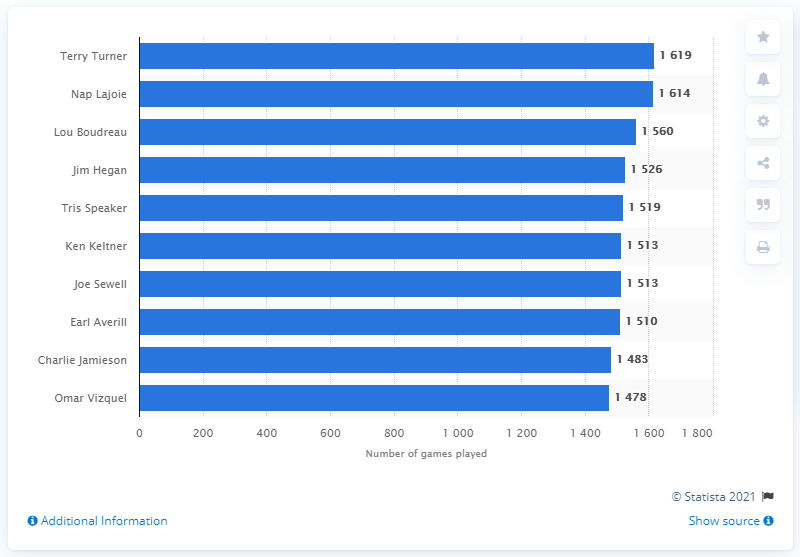List a handful of essential elements in this visual. The answer to the question "Who has played the most games in Indians franchise history?" is Terry Turner. 